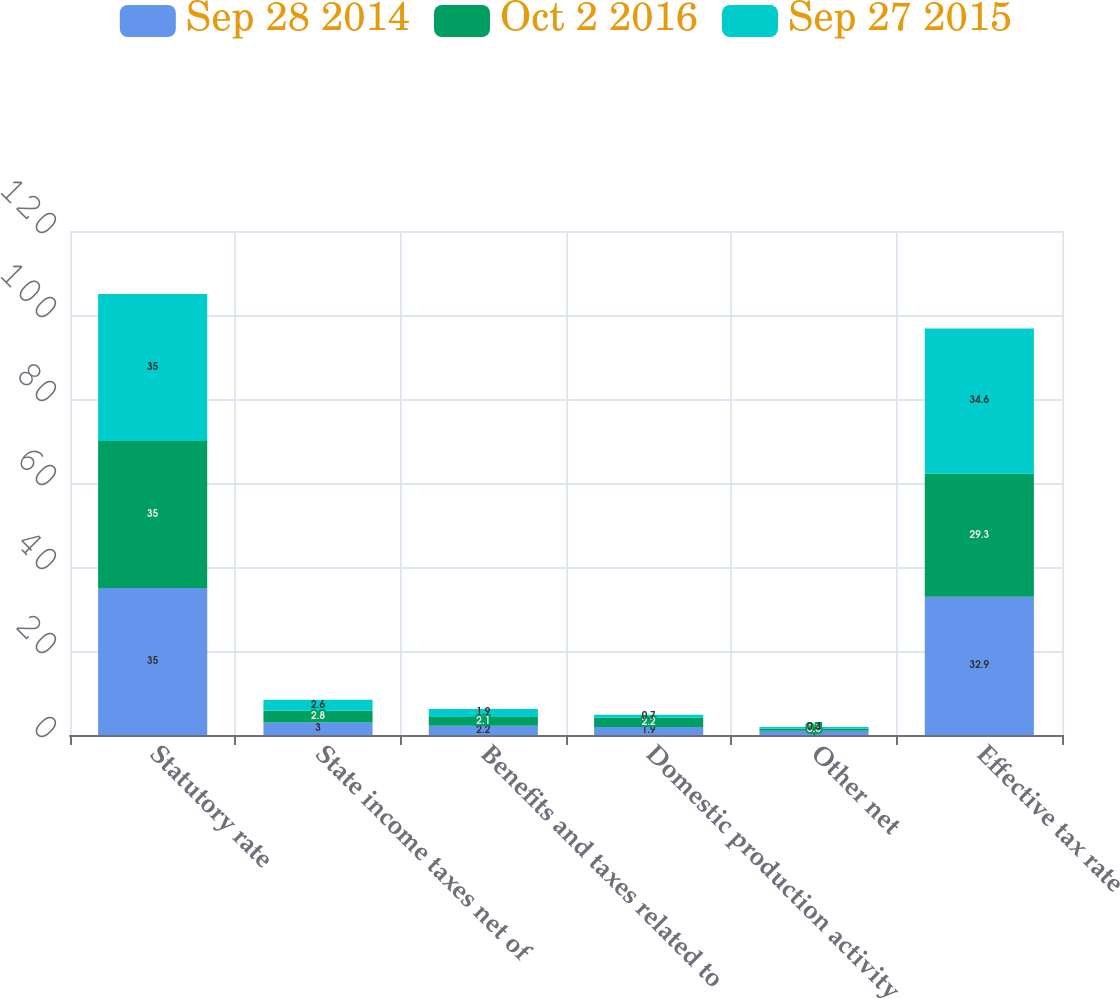Convert chart to OTSL. <chart><loc_0><loc_0><loc_500><loc_500><stacked_bar_chart><ecel><fcel>Statutory rate<fcel>State income taxes net of<fcel>Benefits and taxes related to<fcel>Domestic production activity<fcel>Other net<fcel>Effective tax rate<nl><fcel>Sep 28 2014<fcel>35<fcel>3<fcel>2.2<fcel>1.9<fcel>1<fcel>32.9<nl><fcel>Oct 2 2016<fcel>35<fcel>2.8<fcel>2.1<fcel>2.2<fcel>0.5<fcel>29.3<nl><fcel>Sep 27 2015<fcel>35<fcel>2.6<fcel>1.9<fcel>0.7<fcel>0.4<fcel>34.6<nl></chart> 